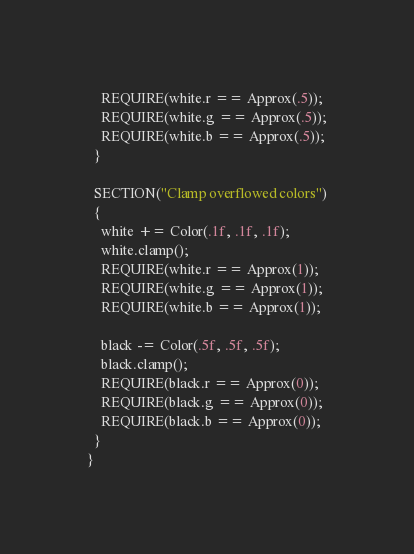<code> <loc_0><loc_0><loc_500><loc_500><_C++_>    REQUIRE(white.r == Approx(.5));
    REQUIRE(white.g == Approx(.5));
    REQUIRE(white.b == Approx(.5));
  }

  SECTION("Clamp overflowed colors")
  {
    white += Color(.1f, .1f, .1f);
    white.clamp();
    REQUIRE(white.r == Approx(1));
    REQUIRE(white.g == Approx(1));
    REQUIRE(white.b == Approx(1));

    black -= Color(.5f, .5f, .5f);
    black.clamp();
    REQUIRE(black.r == Approx(0));
    REQUIRE(black.g == Approx(0));
    REQUIRE(black.b == Approx(0));
  }
}
</code> 